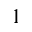<formula> <loc_0><loc_0><loc_500><loc_500>^ { 1 }</formula> 